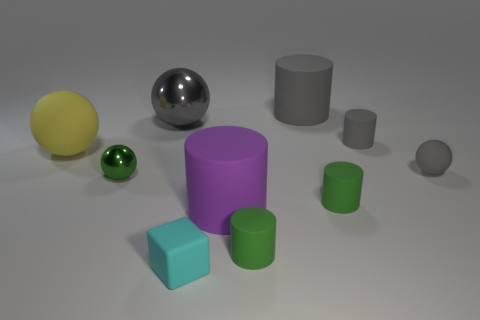What number of objects are small gray cylinders or yellow cylinders?
Your response must be concise. 1. What number of objects are small blue metallic objects or large objects behind the small gray ball?
Your response must be concise. 3. Is the material of the small gray ball the same as the big gray sphere?
Provide a succinct answer. No. What number of other objects are the same material as the big gray cylinder?
Your response must be concise. 7. Are there more tiny cyan rubber objects than small brown metallic balls?
Provide a short and direct response. Yes. Do the big rubber object that is in front of the green shiny sphere and the big gray matte thing have the same shape?
Provide a succinct answer. Yes. Are there fewer tiny cylinders than gray metallic balls?
Your answer should be compact. No. There is a yellow ball that is the same size as the purple matte cylinder; what is it made of?
Provide a succinct answer. Rubber. There is a small metallic thing; is it the same color as the cylinder that is in front of the big purple rubber cylinder?
Ensure brevity in your answer.  Yes. Is the number of green spheres in front of the tiny cyan thing less than the number of tiny red metallic spheres?
Your response must be concise. No. 